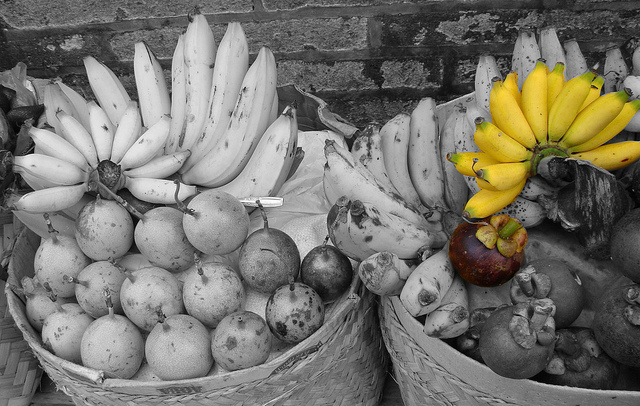Please provide a short description for this region: [0.0, 0.25, 0.31, 0.52]. A cluster of uncolored, small bananas arranged together. 